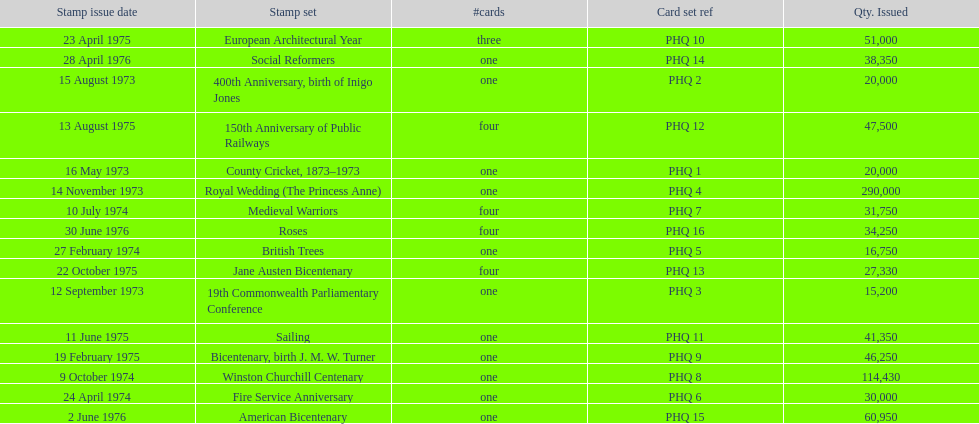Which card was issued most? Royal Wedding (The Princess Anne). 